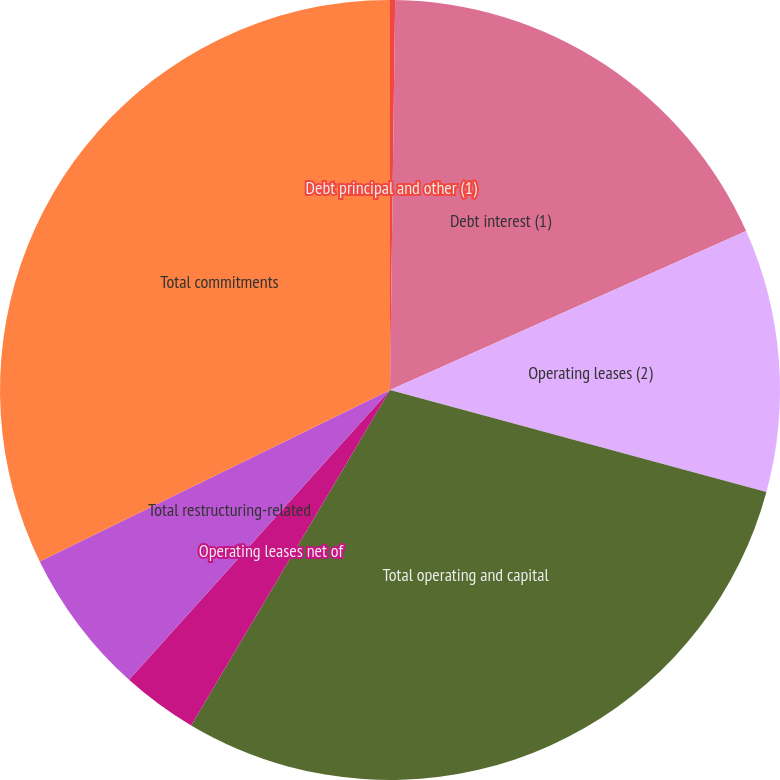Convert chart. <chart><loc_0><loc_0><loc_500><loc_500><pie_chart><fcel>Debt principal and other (1)<fcel>Debt interest (1)<fcel>Operating leases (2)<fcel>Total operating and capital<fcel>Operating leases net of<fcel>Total restructuring-related<fcel>Total commitments<nl><fcel>0.21%<fcel>18.11%<fcel>10.89%<fcel>29.3%<fcel>3.15%<fcel>6.09%<fcel>32.24%<nl></chart> 